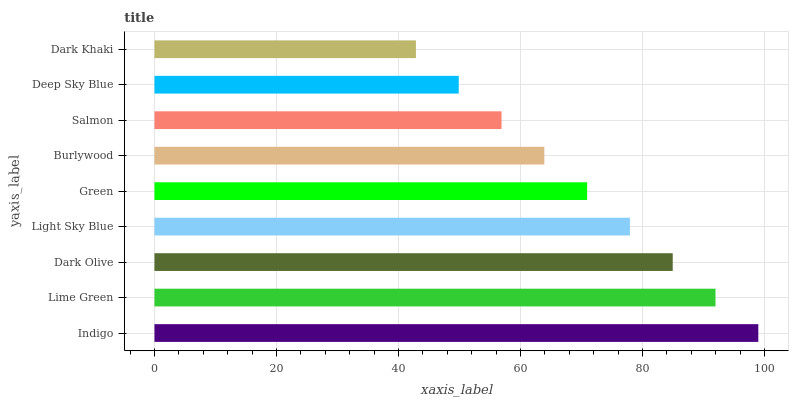Is Dark Khaki the minimum?
Answer yes or no. Yes. Is Indigo the maximum?
Answer yes or no. Yes. Is Lime Green the minimum?
Answer yes or no. No. Is Lime Green the maximum?
Answer yes or no. No. Is Indigo greater than Lime Green?
Answer yes or no. Yes. Is Lime Green less than Indigo?
Answer yes or no. Yes. Is Lime Green greater than Indigo?
Answer yes or no. No. Is Indigo less than Lime Green?
Answer yes or no. No. Is Green the high median?
Answer yes or no. Yes. Is Green the low median?
Answer yes or no. Yes. Is Lime Green the high median?
Answer yes or no. No. Is Indigo the low median?
Answer yes or no. No. 